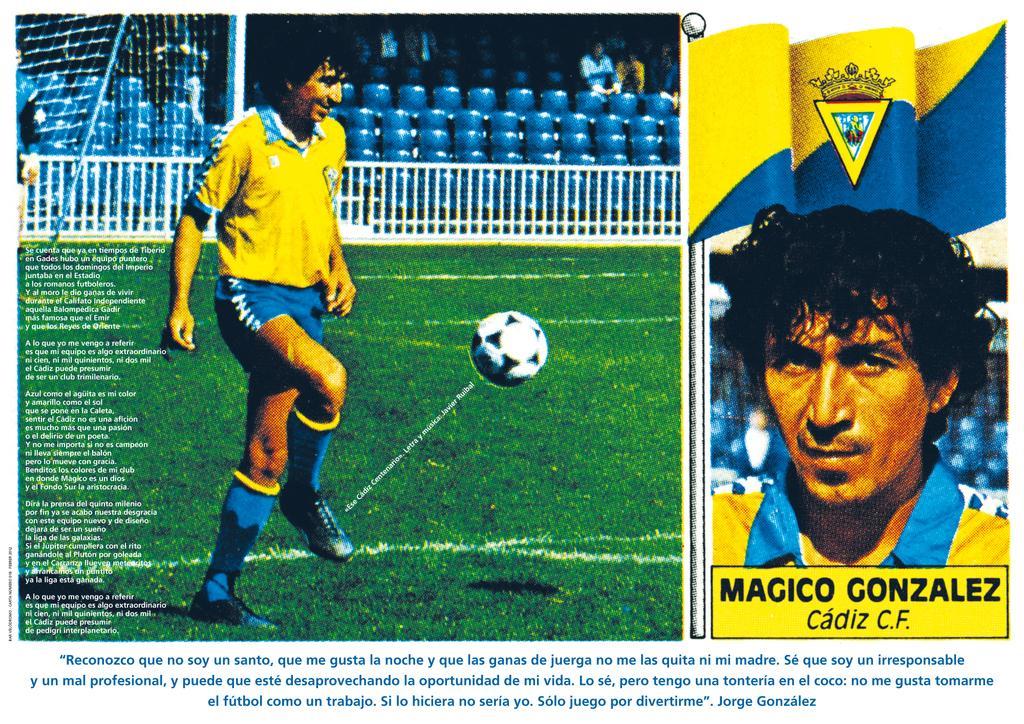Can you describe this image briefly? This is a collage image. In this college image we can see a man standing on the ground, ball and some text. 